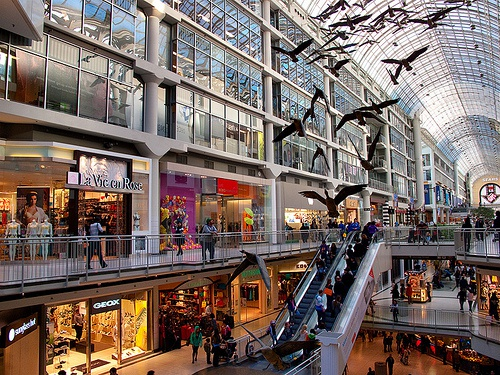Describe the objects in this image and their specific colors. I can see people in brown, black, gray, and maroon tones, bird in brown, white, black, darkgray, and gray tones, bird in brown, black, white, darkgray, and pink tones, bird in brown, black, gray, and maroon tones, and bird in brown, black, gray, maroon, and darkgray tones in this image. 